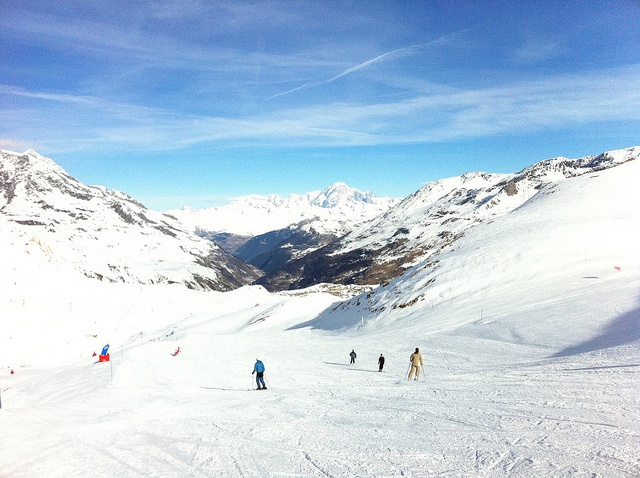Describe the objects in this image and their specific colors. I can see people in gray, black, teal, white, and blue tones, people in gray and tan tones, people in gray, black, darkgray, and lightgray tones, skis in gray, lightgray, darkgray, and black tones, and people in gray and black tones in this image. 